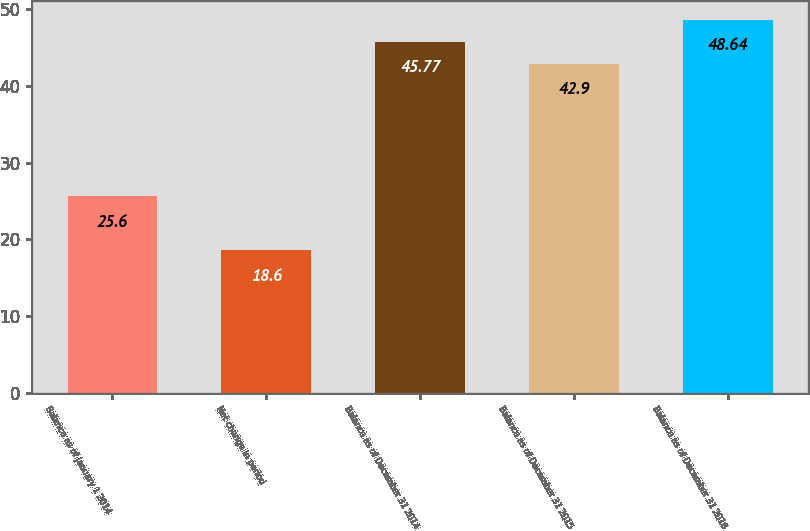Convert chart to OTSL. <chart><loc_0><loc_0><loc_500><loc_500><bar_chart><fcel>Balance as of January 1 2014<fcel>Net change in period<fcel>Balance as of December 31 2014<fcel>Balance as of December 31 2015<fcel>Balance as of December 31 2016<nl><fcel>25.6<fcel>18.6<fcel>45.77<fcel>42.9<fcel>48.64<nl></chart> 